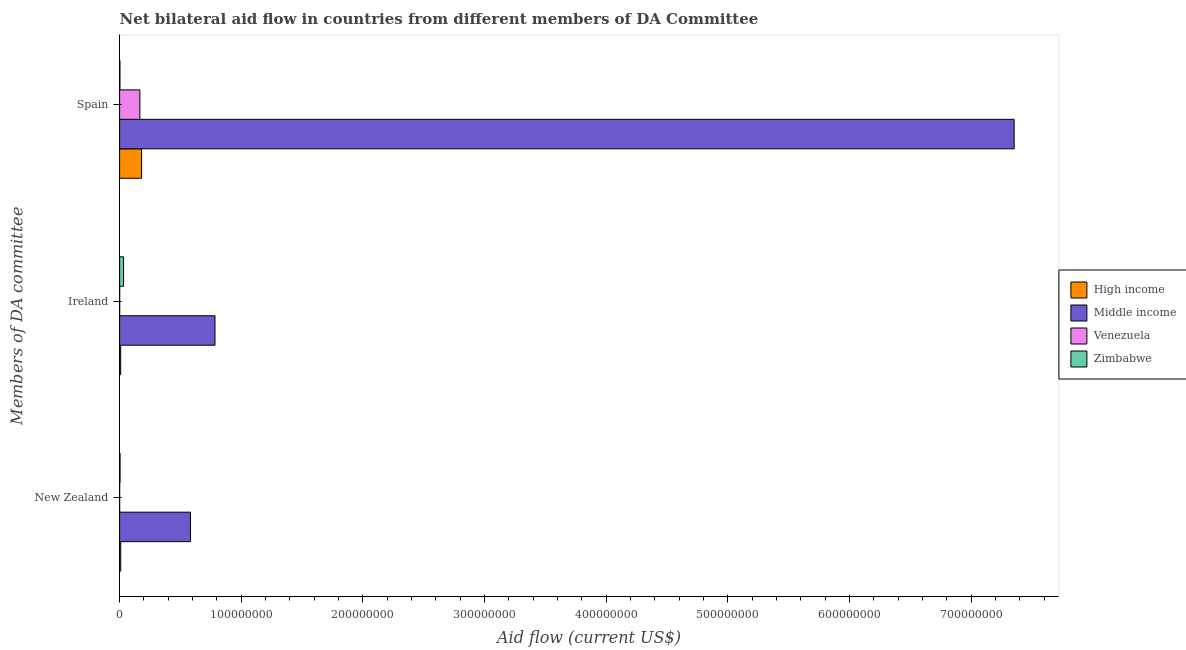How many different coloured bars are there?
Make the answer very short. 4. What is the label of the 3rd group of bars from the top?
Offer a terse response. New Zealand. What is the amount of aid provided by ireland in Venezuela?
Provide a succinct answer. 4.00e+04. Across all countries, what is the maximum amount of aid provided by ireland?
Offer a terse response. 7.84e+07. Across all countries, what is the minimum amount of aid provided by spain?
Keep it short and to the point. 2.70e+05. In which country was the amount of aid provided by spain minimum?
Your response must be concise. Zimbabwe. What is the total amount of aid provided by new zealand in the graph?
Ensure brevity in your answer.  5.96e+07. What is the difference between the amount of aid provided by spain in High income and that in Middle income?
Provide a short and direct response. -7.17e+08. What is the difference between the amount of aid provided by spain in Zimbabwe and the amount of aid provided by new zealand in High income?
Keep it short and to the point. -6.50e+05. What is the average amount of aid provided by spain per country?
Keep it short and to the point. 1.93e+08. What is the difference between the amount of aid provided by ireland and amount of aid provided by new zealand in Venezuela?
Your answer should be compact. 10000. In how many countries, is the amount of aid provided by ireland greater than 240000000 US$?
Offer a terse response. 0. What is the ratio of the amount of aid provided by new zealand in High income to that in Middle income?
Keep it short and to the point. 0.02. Is the amount of aid provided by spain in High income less than that in Zimbabwe?
Make the answer very short. No. Is the difference between the amount of aid provided by new zealand in Zimbabwe and High income greater than the difference between the amount of aid provided by spain in Zimbabwe and High income?
Provide a succinct answer. Yes. What is the difference between the highest and the second highest amount of aid provided by spain?
Offer a very short reply. 7.17e+08. What is the difference between the highest and the lowest amount of aid provided by ireland?
Your answer should be very brief. 7.84e+07. What does the 3rd bar from the top in Ireland represents?
Offer a terse response. Middle income. What does the 4th bar from the bottom in Ireland represents?
Offer a terse response. Zimbabwe. Is it the case that in every country, the sum of the amount of aid provided by new zealand and amount of aid provided by ireland is greater than the amount of aid provided by spain?
Offer a terse response. No. How many bars are there?
Offer a terse response. 12. Are all the bars in the graph horizontal?
Make the answer very short. Yes. Does the graph contain grids?
Your answer should be very brief. No. Where does the legend appear in the graph?
Offer a very short reply. Center right. How many legend labels are there?
Your answer should be compact. 4. What is the title of the graph?
Offer a very short reply. Net bilateral aid flow in countries from different members of DA Committee. Does "Isle of Man" appear as one of the legend labels in the graph?
Keep it short and to the point. No. What is the label or title of the X-axis?
Your answer should be compact. Aid flow (current US$). What is the label or title of the Y-axis?
Make the answer very short. Members of DA committee. What is the Aid flow (current US$) in High income in New Zealand?
Your answer should be very brief. 9.20e+05. What is the Aid flow (current US$) of Middle income in New Zealand?
Offer a terse response. 5.82e+07. What is the Aid flow (current US$) of High income in Ireland?
Offer a terse response. 8.80e+05. What is the Aid flow (current US$) in Middle income in Ireland?
Provide a short and direct response. 7.84e+07. What is the Aid flow (current US$) in Zimbabwe in Ireland?
Your answer should be compact. 3.25e+06. What is the Aid flow (current US$) in High income in Spain?
Keep it short and to the point. 1.81e+07. What is the Aid flow (current US$) in Middle income in Spain?
Your answer should be very brief. 7.35e+08. What is the Aid flow (current US$) of Venezuela in Spain?
Provide a succinct answer. 1.67e+07. Across all Members of DA committee, what is the maximum Aid flow (current US$) of High income?
Your response must be concise. 1.81e+07. Across all Members of DA committee, what is the maximum Aid flow (current US$) in Middle income?
Ensure brevity in your answer.  7.35e+08. Across all Members of DA committee, what is the maximum Aid flow (current US$) of Venezuela?
Keep it short and to the point. 1.67e+07. Across all Members of DA committee, what is the maximum Aid flow (current US$) of Zimbabwe?
Ensure brevity in your answer.  3.25e+06. Across all Members of DA committee, what is the minimum Aid flow (current US$) of High income?
Your response must be concise. 8.80e+05. Across all Members of DA committee, what is the minimum Aid flow (current US$) in Middle income?
Provide a succinct answer. 5.82e+07. Across all Members of DA committee, what is the minimum Aid flow (current US$) of Venezuela?
Your response must be concise. 3.00e+04. Across all Members of DA committee, what is the minimum Aid flow (current US$) in Zimbabwe?
Your answer should be very brief. 2.70e+05. What is the total Aid flow (current US$) of High income in the graph?
Make the answer very short. 1.99e+07. What is the total Aid flow (current US$) in Middle income in the graph?
Give a very brief answer. 8.72e+08. What is the total Aid flow (current US$) in Venezuela in the graph?
Provide a succinct answer. 1.67e+07. What is the total Aid flow (current US$) of Zimbabwe in the graph?
Provide a succinct answer. 3.87e+06. What is the difference between the Aid flow (current US$) in High income in New Zealand and that in Ireland?
Offer a very short reply. 4.00e+04. What is the difference between the Aid flow (current US$) in Middle income in New Zealand and that in Ireland?
Your answer should be compact. -2.02e+07. What is the difference between the Aid flow (current US$) in Venezuela in New Zealand and that in Ireland?
Offer a terse response. -10000. What is the difference between the Aid flow (current US$) in Zimbabwe in New Zealand and that in Ireland?
Offer a terse response. -2.90e+06. What is the difference between the Aid flow (current US$) in High income in New Zealand and that in Spain?
Offer a terse response. -1.72e+07. What is the difference between the Aid flow (current US$) in Middle income in New Zealand and that in Spain?
Provide a succinct answer. -6.77e+08. What is the difference between the Aid flow (current US$) in Venezuela in New Zealand and that in Spain?
Provide a succinct answer. -1.66e+07. What is the difference between the Aid flow (current US$) of High income in Ireland and that in Spain?
Your answer should be very brief. -1.72e+07. What is the difference between the Aid flow (current US$) of Middle income in Ireland and that in Spain?
Give a very brief answer. -6.57e+08. What is the difference between the Aid flow (current US$) of Venezuela in Ireland and that in Spain?
Keep it short and to the point. -1.66e+07. What is the difference between the Aid flow (current US$) of Zimbabwe in Ireland and that in Spain?
Keep it short and to the point. 2.98e+06. What is the difference between the Aid flow (current US$) in High income in New Zealand and the Aid flow (current US$) in Middle income in Ireland?
Provide a short and direct response. -7.75e+07. What is the difference between the Aid flow (current US$) of High income in New Zealand and the Aid flow (current US$) of Venezuela in Ireland?
Give a very brief answer. 8.80e+05. What is the difference between the Aid flow (current US$) of High income in New Zealand and the Aid flow (current US$) of Zimbabwe in Ireland?
Ensure brevity in your answer.  -2.33e+06. What is the difference between the Aid flow (current US$) in Middle income in New Zealand and the Aid flow (current US$) in Venezuela in Ireland?
Your answer should be very brief. 5.82e+07. What is the difference between the Aid flow (current US$) in Middle income in New Zealand and the Aid flow (current US$) in Zimbabwe in Ireland?
Provide a succinct answer. 5.50e+07. What is the difference between the Aid flow (current US$) in Venezuela in New Zealand and the Aid flow (current US$) in Zimbabwe in Ireland?
Offer a very short reply. -3.22e+06. What is the difference between the Aid flow (current US$) of High income in New Zealand and the Aid flow (current US$) of Middle income in Spain?
Your response must be concise. -7.35e+08. What is the difference between the Aid flow (current US$) of High income in New Zealand and the Aid flow (current US$) of Venezuela in Spain?
Offer a very short reply. -1.57e+07. What is the difference between the Aid flow (current US$) in High income in New Zealand and the Aid flow (current US$) in Zimbabwe in Spain?
Your answer should be very brief. 6.50e+05. What is the difference between the Aid flow (current US$) of Middle income in New Zealand and the Aid flow (current US$) of Venezuela in Spain?
Your response must be concise. 4.16e+07. What is the difference between the Aid flow (current US$) of Middle income in New Zealand and the Aid flow (current US$) of Zimbabwe in Spain?
Your response must be concise. 5.80e+07. What is the difference between the Aid flow (current US$) in Venezuela in New Zealand and the Aid flow (current US$) in Zimbabwe in Spain?
Give a very brief answer. -2.40e+05. What is the difference between the Aid flow (current US$) of High income in Ireland and the Aid flow (current US$) of Middle income in Spain?
Your answer should be very brief. -7.35e+08. What is the difference between the Aid flow (current US$) of High income in Ireland and the Aid flow (current US$) of Venezuela in Spain?
Give a very brief answer. -1.58e+07. What is the difference between the Aid flow (current US$) in High income in Ireland and the Aid flow (current US$) in Zimbabwe in Spain?
Provide a succinct answer. 6.10e+05. What is the difference between the Aid flow (current US$) of Middle income in Ireland and the Aid flow (current US$) of Venezuela in Spain?
Ensure brevity in your answer.  6.18e+07. What is the difference between the Aid flow (current US$) in Middle income in Ireland and the Aid flow (current US$) in Zimbabwe in Spain?
Make the answer very short. 7.82e+07. What is the average Aid flow (current US$) in High income per Members of DA committee?
Your answer should be very brief. 6.63e+06. What is the average Aid flow (current US$) in Middle income per Members of DA committee?
Provide a succinct answer. 2.91e+08. What is the average Aid flow (current US$) in Venezuela per Members of DA committee?
Make the answer very short. 5.58e+06. What is the average Aid flow (current US$) of Zimbabwe per Members of DA committee?
Your answer should be compact. 1.29e+06. What is the difference between the Aid flow (current US$) in High income and Aid flow (current US$) in Middle income in New Zealand?
Your answer should be compact. -5.73e+07. What is the difference between the Aid flow (current US$) in High income and Aid flow (current US$) in Venezuela in New Zealand?
Offer a terse response. 8.90e+05. What is the difference between the Aid flow (current US$) of High income and Aid flow (current US$) of Zimbabwe in New Zealand?
Ensure brevity in your answer.  5.70e+05. What is the difference between the Aid flow (current US$) of Middle income and Aid flow (current US$) of Venezuela in New Zealand?
Keep it short and to the point. 5.82e+07. What is the difference between the Aid flow (current US$) of Middle income and Aid flow (current US$) of Zimbabwe in New Zealand?
Give a very brief answer. 5.79e+07. What is the difference between the Aid flow (current US$) of Venezuela and Aid flow (current US$) of Zimbabwe in New Zealand?
Your response must be concise. -3.20e+05. What is the difference between the Aid flow (current US$) in High income and Aid flow (current US$) in Middle income in Ireland?
Your answer should be compact. -7.76e+07. What is the difference between the Aid flow (current US$) of High income and Aid flow (current US$) of Venezuela in Ireland?
Provide a succinct answer. 8.40e+05. What is the difference between the Aid flow (current US$) of High income and Aid flow (current US$) of Zimbabwe in Ireland?
Make the answer very short. -2.37e+06. What is the difference between the Aid flow (current US$) of Middle income and Aid flow (current US$) of Venezuela in Ireland?
Provide a succinct answer. 7.84e+07. What is the difference between the Aid flow (current US$) of Middle income and Aid flow (current US$) of Zimbabwe in Ireland?
Keep it short and to the point. 7.52e+07. What is the difference between the Aid flow (current US$) in Venezuela and Aid flow (current US$) in Zimbabwe in Ireland?
Make the answer very short. -3.21e+06. What is the difference between the Aid flow (current US$) in High income and Aid flow (current US$) in Middle income in Spain?
Ensure brevity in your answer.  -7.17e+08. What is the difference between the Aid flow (current US$) in High income and Aid flow (current US$) in Venezuela in Spain?
Your response must be concise. 1.42e+06. What is the difference between the Aid flow (current US$) of High income and Aid flow (current US$) of Zimbabwe in Spain?
Keep it short and to the point. 1.78e+07. What is the difference between the Aid flow (current US$) in Middle income and Aid flow (current US$) in Venezuela in Spain?
Offer a very short reply. 7.19e+08. What is the difference between the Aid flow (current US$) of Middle income and Aid flow (current US$) of Zimbabwe in Spain?
Keep it short and to the point. 7.35e+08. What is the difference between the Aid flow (current US$) of Venezuela and Aid flow (current US$) of Zimbabwe in Spain?
Give a very brief answer. 1.64e+07. What is the ratio of the Aid flow (current US$) of High income in New Zealand to that in Ireland?
Offer a terse response. 1.05. What is the ratio of the Aid flow (current US$) of Middle income in New Zealand to that in Ireland?
Your response must be concise. 0.74. What is the ratio of the Aid flow (current US$) in Zimbabwe in New Zealand to that in Ireland?
Keep it short and to the point. 0.11. What is the ratio of the Aid flow (current US$) of High income in New Zealand to that in Spain?
Provide a succinct answer. 0.05. What is the ratio of the Aid flow (current US$) of Middle income in New Zealand to that in Spain?
Ensure brevity in your answer.  0.08. What is the ratio of the Aid flow (current US$) of Venezuela in New Zealand to that in Spain?
Your response must be concise. 0. What is the ratio of the Aid flow (current US$) of Zimbabwe in New Zealand to that in Spain?
Offer a very short reply. 1.3. What is the ratio of the Aid flow (current US$) of High income in Ireland to that in Spain?
Your response must be concise. 0.05. What is the ratio of the Aid flow (current US$) of Middle income in Ireland to that in Spain?
Keep it short and to the point. 0.11. What is the ratio of the Aid flow (current US$) of Venezuela in Ireland to that in Spain?
Your response must be concise. 0. What is the ratio of the Aid flow (current US$) in Zimbabwe in Ireland to that in Spain?
Your answer should be very brief. 12.04. What is the difference between the highest and the second highest Aid flow (current US$) in High income?
Keep it short and to the point. 1.72e+07. What is the difference between the highest and the second highest Aid flow (current US$) in Middle income?
Make the answer very short. 6.57e+08. What is the difference between the highest and the second highest Aid flow (current US$) in Venezuela?
Your response must be concise. 1.66e+07. What is the difference between the highest and the second highest Aid flow (current US$) in Zimbabwe?
Keep it short and to the point. 2.90e+06. What is the difference between the highest and the lowest Aid flow (current US$) in High income?
Your answer should be very brief. 1.72e+07. What is the difference between the highest and the lowest Aid flow (current US$) of Middle income?
Ensure brevity in your answer.  6.77e+08. What is the difference between the highest and the lowest Aid flow (current US$) of Venezuela?
Keep it short and to the point. 1.66e+07. What is the difference between the highest and the lowest Aid flow (current US$) in Zimbabwe?
Keep it short and to the point. 2.98e+06. 